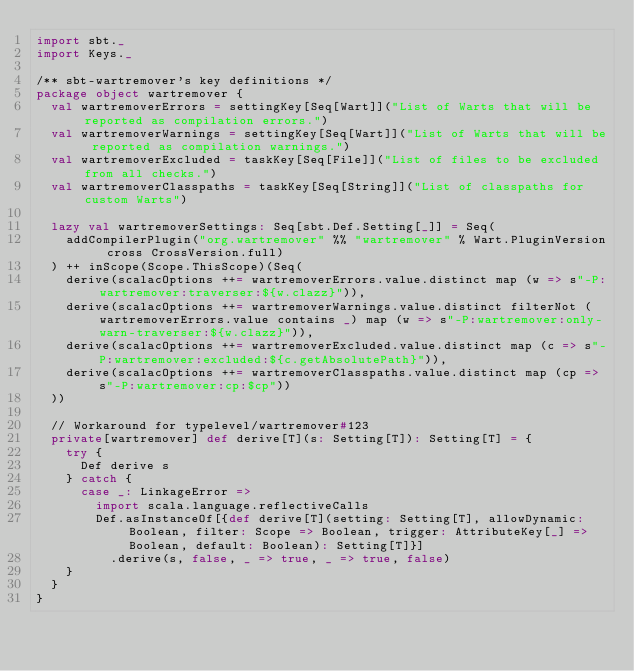Convert code to text. <code><loc_0><loc_0><loc_500><loc_500><_Scala_>import sbt._
import Keys._

/** sbt-wartremover's key definitions */
package object wartremover {
  val wartremoverErrors = settingKey[Seq[Wart]]("List of Warts that will be reported as compilation errors.")
  val wartremoverWarnings = settingKey[Seq[Wart]]("List of Warts that will be reported as compilation warnings.")
  val wartremoverExcluded = taskKey[Seq[File]]("List of files to be excluded from all checks.")
  val wartremoverClasspaths = taskKey[Seq[String]]("List of classpaths for custom Warts")

  lazy val wartremoverSettings: Seq[sbt.Def.Setting[_]] = Seq(
    addCompilerPlugin("org.wartremover" %% "wartremover" % Wart.PluginVersion cross CrossVersion.full)
  ) ++ inScope(Scope.ThisScope)(Seq(
    derive(scalacOptions ++= wartremoverErrors.value.distinct map (w => s"-P:wartremover:traverser:${w.clazz}")),
    derive(scalacOptions ++= wartremoverWarnings.value.distinct filterNot (wartremoverErrors.value contains _) map (w => s"-P:wartremover:only-warn-traverser:${w.clazz}")),
    derive(scalacOptions ++= wartremoverExcluded.value.distinct map (c => s"-P:wartremover:excluded:${c.getAbsolutePath}")),
    derive(scalacOptions ++= wartremoverClasspaths.value.distinct map (cp => s"-P:wartremover:cp:$cp"))
  ))

  // Workaround for typelevel/wartremover#123
  private[wartremover] def derive[T](s: Setting[T]): Setting[T] = {
    try {
      Def derive s
    } catch {
      case _: LinkageError =>
        import scala.language.reflectiveCalls
        Def.asInstanceOf[{def derive[T](setting: Setting[T], allowDynamic: Boolean, filter: Scope => Boolean, trigger: AttributeKey[_] => Boolean, default: Boolean): Setting[T]}]
          .derive(s, false, _ => true, _ => true, false)
    }
  }
}
</code> 